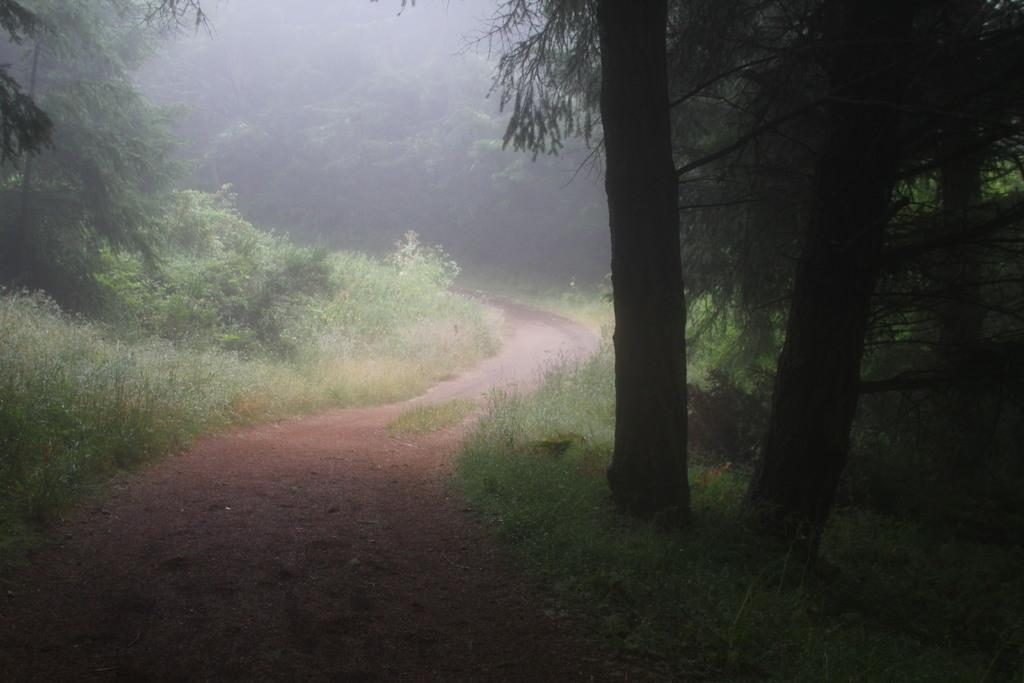What type of setting is depicted in the image? The image is an outside view. What can be seen in the middle of the image? There is a path in the middle of the image. What is present on both sides of the path? Grass and plants are visible on both sides of the path. What can be seen in the background of the image? There are many trees in the background of the image. What type of silk is being used to decorate the jellyfish in the image? There are no jellyfish or silk present in the image; it is an outside view with a path, grass, plants, and trees. 